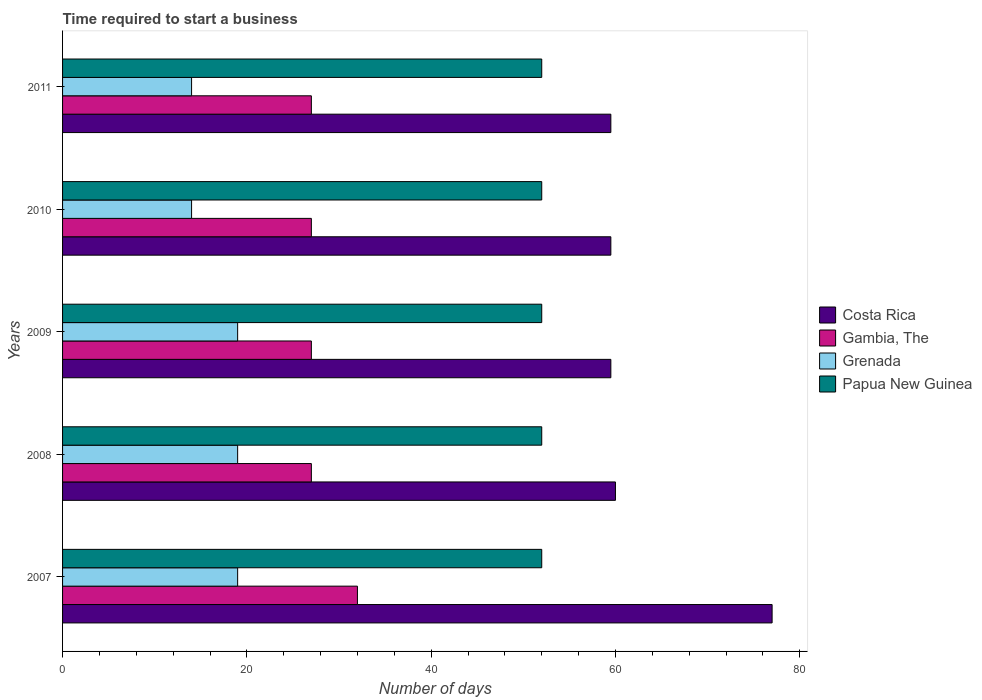How many different coloured bars are there?
Provide a succinct answer. 4. How many groups of bars are there?
Ensure brevity in your answer.  5. Are the number of bars per tick equal to the number of legend labels?
Ensure brevity in your answer.  Yes. How many bars are there on the 1st tick from the top?
Offer a very short reply. 4. How many bars are there on the 3rd tick from the bottom?
Your answer should be compact. 4. What is the label of the 5th group of bars from the top?
Ensure brevity in your answer.  2007. In how many cases, is the number of bars for a given year not equal to the number of legend labels?
Make the answer very short. 0. What is the number of days required to start a business in Costa Rica in 2009?
Keep it short and to the point. 59.5. Across all years, what is the maximum number of days required to start a business in Gambia, The?
Make the answer very short. 32. Across all years, what is the minimum number of days required to start a business in Costa Rica?
Make the answer very short. 59.5. What is the total number of days required to start a business in Papua New Guinea in the graph?
Your answer should be compact. 260. What is the difference between the number of days required to start a business in Papua New Guinea in 2008 and that in 2010?
Ensure brevity in your answer.  0. What is the average number of days required to start a business in Costa Rica per year?
Give a very brief answer. 63.1. What is the ratio of the number of days required to start a business in Papua New Guinea in 2008 to that in 2009?
Make the answer very short. 1. What is the difference between the highest and the lowest number of days required to start a business in Costa Rica?
Keep it short and to the point. 17.5. In how many years, is the number of days required to start a business in Costa Rica greater than the average number of days required to start a business in Costa Rica taken over all years?
Offer a very short reply. 1. Is it the case that in every year, the sum of the number of days required to start a business in Grenada and number of days required to start a business in Costa Rica is greater than the sum of number of days required to start a business in Gambia, The and number of days required to start a business in Papua New Guinea?
Provide a succinct answer. No. What does the 1st bar from the top in 2009 represents?
Offer a very short reply. Papua New Guinea. What does the 2nd bar from the bottom in 2009 represents?
Your response must be concise. Gambia, The. Is it the case that in every year, the sum of the number of days required to start a business in Costa Rica and number of days required to start a business in Gambia, The is greater than the number of days required to start a business in Papua New Guinea?
Your answer should be very brief. Yes. How many bars are there?
Make the answer very short. 20. How many years are there in the graph?
Your answer should be compact. 5. What is the title of the graph?
Your answer should be very brief. Time required to start a business. What is the label or title of the X-axis?
Give a very brief answer. Number of days. What is the label or title of the Y-axis?
Give a very brief answer. Years. What is the Number of days of Costa Rica in 2007?
Offer a terse response. 77. What is the Number of days in Gambia, The in 2007?
Provide a short and direct response. 32. What is the Number of days in Grenada in 2007?
Provide a succinct answer. 19. What is the Number of days of Papua New Guinea in 2007?
Give a very brief answer. 52. What is the Number of days of Costa Rica in 2008?
Keep it short and to the point. 60. What is the Number of days in Costa Rica in 2009?
Offer a terse response. 59.5. What is the Number of days in Grenada in 2009?
Provide a short and direct response. 19. What is the Number of days of Papua New Guinea in 2009?
Make the answer very short. 52. What is the Number of days of Costa Rica in 2010?
Ensure brevity in your answer.  59.5. What is the Number of days of Grenada in 2010?
Provide a short and direct response. 14. What is the Number of days in Papua New Guinea in 2010?
Ensure brevity in your answer.  52. What is the Number of days of Costa Rica in 2011?
Give a very brief answer. 59.5. What is the Number of days of Gambia, The in 2011?
Your answer should be very brief. 27. What is the Number of days of Grenada in 2011?
Your answer should be compact. 14. Across all years, what is the maximum Number of days in Costa Rica?
Your answer should be compact. 77. Across all years, what is the maximum Number of days in Grenada?
Your answer should be very brief. 19. Across all years, what is the minimum Number of days in Costa Rica?
Ensure brevity in your answer.  59.5. Across all years, what is the minimum Number of days of Gambia, The?
Give a very brief answer. 27. Across all years, what is the minimum Number of days of Papua New Guinea?
Give a very brief answer. 52. What is the total Number of days in Costa Rica in the graph?
Offer a terse response. 315.5. What is the total Number of days of Gambia, The in the graph?
Ensure brevity in your answer.  140. What is the total Number of days of Papua New Guinea in the graph?
Ensure brevity in your answer.  260. What is the difference between the Number of days of Costa Rica in 2007 and that in 2008?
Your answer should be compact. 17. What is the difference between the Number of days in Gambia, The in 2007 and that in 2008?
Provide a succinct answer. 5. What is the difference between the Number of days of Grenada in 2007 and that in 2008?
Your response must be concise. 0. What is the difference between the Number of days of Costa Rica in 2007 and that in 2009?
Ensure brevity in your answer.  17.5. What is the difference between the Number of days in Gambia, The in 2007 and that in 2010?
Provide a short and direct response. 5. What is the difference between the Number of days in Papua New Guinea in 2007 and that in 2010?
Ensure brevity in your answer.  0. What is the difference between the Number of days in Costa Rica in 2008 and that in 2009?
Offer a terse response. 0.5. What is the difference between the Number of days of Gambia, The in 2008 and that in 2009?
Offer a terse response. 0. What is the difference between the Number of days of Grenada in 2008 and that in 2009?
Your response must be concise. 0. What is the difference between the Number of days of Grenada in 2008 and that in 2010?
Offer a very short reply. 5. What is the difference between the Number of days of Costa Rica in 2008 and that in 2011?
Your answer should be compact. 0.5. What is the difference between the Number of days of Gambia, The in 2009 and that in 2010?
Ensure brevity in your answer.  0. What is the difference between the Number of days of Gambia, The in 2009 and that in 2011?
Ensure brevity in your answer.  0. What is the difference between the Number of days of Grenada in 2009 and that in 2011?
Provide a succinct answer. 5. What is the difference between the Number of days in Papua New Guinea in 2009 and that in 2011?
Give a very brief answer. 0. What is the difference between the Number of days in Gambia, The in 2010 and that in 2011?
Offer a very short reply. 0. What is the difference between the Number of days of Papua New Guinea in 2010 and that in 2011?
Ensure brevity in your answer.  0. What is the difference between the Number of days in Costa Rica in 2007 and the Number of days in Grenada in 2008?
Your answer should be very brief. 58. What is the difference between the Number of days in Costa Rica in 2007 and the Number of days in Papua New Guinea in 2008?
Offer a very short reply. 25. What is the difference between the Number of days of Gambia, The in 2007 and the Number of days of Grenada in 2008?
Your response must be concise. 13. What is the difference between the Number of days in Gambia, The in 2007 and the Number of days in Papua New Guinea in 2008?
Offer a very short reply. -20. What is the difference between the Number of days of Grenada in 2007 and the Number of days of Papua New Guinea in 2008?
Your answer should be compact. -33. What is the difference between the Number of days of Costa Rica in 2007 and the Number of days of Grenada in 2009?
Keep it short and to the point. 58. What is the difference between the Number of days of Grenada in 2007 and the Number of days of Papua New Guinea in 2009?
Provide a short and direct response. -33. What is the difference between the Number of days of Costa Rica in 2007 and the Number of days of Gambia, The in 2010?
Offer a very short reply. 50. What is the difference between the Number of days in Costa Rica in 2007 and the Number of days in Grenada in 2010?
Offer a terse response. 63. What is the difference between the Number of days of Gambia, The in 2007 and the Number of days of Grenada in 2010?
Give a very brief answer. 18. What is the difference between the Number of days in Grenada in 2007 and the Number of days in Papua New Guinea in 2010?
Your answer should be very brief. -33. What is the difference between the Number of days in Costa Rica in 2007 and the Number of days in Papua New Guinea in 2011?
Offer a very short reply. 25. What is the difference between the Number of days of Grenada in 2007 and the Number of days of Papua New Guinea in 2011?
Ensure brevity in your answer.  -33. What is the difference between the Number of days of Costa Rica in 2008 and the Number of days of Gambia, The in 2009?
Offer a very short reply. 33. What is the difference between the Number of days of Costa Rica in 2008 and the Number of days of Grenada in 2009?
Provide a succinct answer. 41. What is the difference between the Number of days of Costa Rica in 2008 and the Number of days of Papua New Guinea in 2009?
Ensure brevity in your answer.  8. What is the difference between the Number of days in Gambia, The in 2008 and the Number of days in Grenada in 2009?
Provide a short and direct response. 8. What is the difference between the Number of days of Grenada in 2008 and the Number of days of Papua New Guinea in 2009?
Ensure brevity in your answer.  -33. What is the difference between the Number of days of Costa Rica in 2008 and the Number of days of Gambia, The in 2010?
Your response must be concise. 33. What is the difference between the Number of days in Costa Rica in 2008 and the Number of days in Papua New Guinea in 2010?
Your answer should be compact. 8. What is the difference between the Number of days of Gambia, The in 2008 and the Number of days of Grenada in 2010?
Your answer should be very brief. 13. What is the difference between the Number of days in Gambia, The in 2008 and the Number of days in Papua New Guinea in 2010?
Make the answer very short. -25. What is the difference between the Number of days of Grenada in 2008 and the Number of days of Papua New Guinea in 2010?
Make the answer very short. -33. What is the difference between the Number of days in Costa Rica in 2008 and the Number of days in Gambia, The in 2011?
Make the answer very short. 33. What is the difference between the Number of days in Grenada in 2008 and the Number of days in Papua New Guinea in 2011?
Keep it short and to the point. -33. What is the difference between the Number of days in Costa Rica in 2009 and the Number of days in Gambia, The in 2010?
Provide a short and direct response. 32.5. What is the difference between the Number of days of Costa Rica in 2009 and the Number of days of Grenada in 2010?
Your answer should be compact. 45.5. What is the difference between the Number of days in Gambia, The in 2009 and the Number of days in Papua New Guinea in 2010?
Ensure brevity in your answer.  -25. What is the difference between the Number of days in Grenada in 2009 and the Number of days in Papua New Guinea in 2010?
Ensure brevity in your answer.  -33. What is the difference between the Number of days of Costa Rica in 2009 and the Number of days of Gambia, The in 2011?
Provide a short and direct response. 32.5. What is the difference between the Number of days of Costa Rica in 2009 and the Number of days of Grenada in 2011?
Provide a succinct answer. 45.5. What is the difference between the Number of days in Costa Rica in 2009 and the Number of days in Papua New Guinea in 2011?
Offer a very short reply. 7.5. What is the difference between the Number of days in Gambia, The in 2009 and the Number of days in Grenada in 2011?
Your answer should be compact. 13. What is the difference between the Number of days of Grenada in 2009 and the Number of days of Papua New Guinea in 2011?
Keep it short and to the point. -33. What is the difference between the Number of days in Costa Rica in 2010 and the Number of days in Gambia, The in 2011?
Provide a short and direct response. 32.5. What is the difference between the Number of days in Costa Rica in 2010 and the Number of days in Grenada in 2011?
Give a very brief answer. 45.5. What is the difference between the Number of days in Gambia, The in 2010 and the Number of days in Grenada in 2011?
Offer a terse response. 13. What is the difference between the Number of days of Gambia, The in 2010 and the Number of days of Papua New Guinea in 2011?
Make the answer very short. -25. What is the difference between the Number of days in Grenada in 2010 and the Number of days in Papua New Guinea in 2011?
Provide a short and direct response. -38. What is the average Number of days of Costa Rica per year?
Provide a short and direct response. 63.1. What is the average Number of days in Gambia, The per year?
Your answer should be very brief. 28. In the year 2007, what is the difference between the Number of days of Costa Rica and Number of days of Gambia, The?
Make the answer very short. 45. In the year 2007, what is the difference between the Number of days in Costa Rica and Number of days in Papua New Guinea?
Provide a succinct answer. 25. In the year 2007, what is the difference between the Number of days of Gambia, The and Number of days of Grenada?
Give a very brief answer. 13. In the year 2007, what is the difference between the Number of days in Grenada and Number of days in Papua New Guinea?
Provide a short and direct response. -33. In the year 2008, what is the difference between the Number of days in Costa Rica and Number of days in Gambia, The?
Offer a terse response. 33. In the year 2008, what is the difference between the Number of days of Costa Rica and Number of days of Grenada?
Provide a succinct answer. 41. In the year 2008, what is the difference between the Number of days in Costa Rica and Number of days in Papua New Guinea?
Provide a succinct answer. 8. In the year 2008, what is the difference between the Number of days in Gambia, The and Number of days in Grenada?
Offer a terse response. 8. In the year 2008, what is the difference between the Number of days in Gambia, The and Number of days in Papua New Guinea?
Offer a terse response. -25. In the year 2008, what is the difference between the Number of days of Grenada and Number of days of Papua New Guinea?
Provide a succinct answer. -33. In the year 2009, what is the difference between the Number of days of Costa Rica and Number of days of Gambia, The?
Provide a succinct answer. 32.5. In the year 2009, what is the difference between the Number of days of Costa Rica and Number of days of Grenada?
Make the answer very short. 40.5. In the year 2009, what is the difference between the Number of days in Costa Rica and Number of days in Papua New Guinea?
Offer a very short reply. 7.5. In the year 2009, what is the difference between the Number of days of Grenada and Number of days of Papua New Guinea?
Make the answer very short. -33. In the year 2010, what is the difference between the Number of days in Costa Rica and Number of days in Gambia, The?
Provide a succinct answer. 32.5. In the year 2010, what is the difference between the Number of days in Costa Rica and Number of days in Grenada?
Keep it short and to the point. 45.5. In the year 2010, what is the difference between the Number of days of Gambia, The and Number of days of Grenada?
Offer a very short reply. 13. In the year 2010, what is the difference between the Number of days of Gambia, The and Number of days of Papua New Guinea?
Give a very brief answer. -25. In the year 2010, what is the difference between the Number of days of Grenada and Number of days of Papua New Guinea?
Your response must be concise. -38. In the year 2011, what is the difference between the Number of days of Costa Rica and Number of days of Gambia, The?
Make the answer very short. 32.5. In the year 2011, what is the difference between the Number of days in Costa Rica and Number of days in Grenada?
Provide a short and direct response. 45.5. In the year 2011, what is the difference between the Number of days of Gambia, The and Number of days of Grenada?
Offer a terse response. 13. In the year 2011, what is the difference between the Number of days of Gambia, The and Number of days of Papua New Guinea?
Your response must be concise. -25. In the year 2011, what is the difference between the Number of days in Grenada and Number of days in Papua New Guinea?
Offer a terse response. -38. What is the ratio of the Number of days in Costa Rica in 2007 to that in 2008?
Give a very brief answer. 1.28. What is the ratio of the Number of days of Gambia, The in 2007 to that in 2008?
Ensure brevity in your answer.  1.19. What is the ratio of the Number of days of Costa Rica in 2007 to that in 2009?
Your answer should be compact. 1.29. What is the ratio of the Number of days of Gambia, The in 2007 to that in 2009?
Offer a very short reply. 1.19. What is the ratio of the Number of days of Costa Rica in 2007 to that in 2010?
Ensure brevity in your answer.  1.29. What is the ratio of the Number of days of Gambia, The in 2007 to that in 2010?
Your response must be concise. 1.19. What is the ratio of the Number of days of Grenada in 2007 to that in 2010?
Provide a short and direct response. 1.36. What is the ratio of the Number of days of Costa Rica in 2007 to that in 2011?
Keep it short and to the point. 1.29. What is the ratio of the Number of days in Gambia, The in 2007 to that in 2011?
Provide a short and direct response. 1.19. What is the ratio of the Number of days of Grenada in 2007 to that in 2011?
Keep it short and to the point. 1.36. What is the ratio of the Number of days of Papua New Guinea in 2007 to that in 2011?
Your answer should be very brief. 1. What is the ratio of the Number of days of Costa Rica in 2008 to that in 2009?
Provide a succinct answer. 1.01. What is the ratio of the Number of days of Grenada in 2008 to that in 2009?
Give a very brief answer. 1. What is the ratio of the Number of days of Papua New Guinea in 2008 to that in 2009?
Keep it short and to the point. 1. What is the ratio of the Number of days in Costa Rica in 2008 to that in 2010?
Your answer should be very brief. 1.01. What is the ratio of the Number of days of Gambia, The in 2008 to that in 2010?
Your response must be concise. 1. What is the ratio of the Number of days in Grenada in 2008 to that in 2010?
Provide a succinct answer. 1.36. What is the ratio of the Number of days of Papua New Guinea in 2008 to that in 2010?
Your response must be concise. 1. What is the ratio of the Number of days in Costa Rica in 2008 to that in 2011?
Make the answer very short. 1.01. What is the ratio of the Number of days in Gambia, The in 2008 to that in 2011?
Provide a short and direct response. 1. What is the ratio of the Number of days in Grenada in 2008 to that in 2011?
Provide a short and direct response. 1.36. What is the ratio of the Number of days of Costa Rica in 2009 to that in 2010?
Offer a very short reply. 1. What is the ratio of the Number of days in Gambia, The in 2009 to that in 2010?
Offer a terse response. 1. What is the ratio of the Number of days in Grenada in 2009 to that in 2010?
Your answer should be very brief. 1.36. What is the ratio of the Number of days of Papua New Guinea in 2009 to that in 2010?
Give a very brief answer. 1. What is the ratio of the Number of days in Costa Rica in 2009 to that in 2011?
Give a very brief answer. 1. What is the ratio of the Number of days of Grenada in 2009 to that in 2011?
Provide a short and direct response. 1.36. What is the ratio of the Number of days in Costa Rica in 2010 to that in 2011?
Offer a terse response. 1. What is the ratio of the Number of days of Gambia, The in 2010 to that in 2011?
Your response must be concise. 1. What is the ratio of the Number of days in Papua New Guinea in 2010 to that in 2011?
Give a very brief answer. 1. What is the difference between the highest and the second highest Number of days in Costa Rica?
Keep it short and to the point. 17. What is the difference between the highest and the second highest Number of days in Grenada?
Your response must be concise. 0. What is the difference between the highest and the second highest Number of days in Papua New Guinea?
Your response must be concise. 0. 